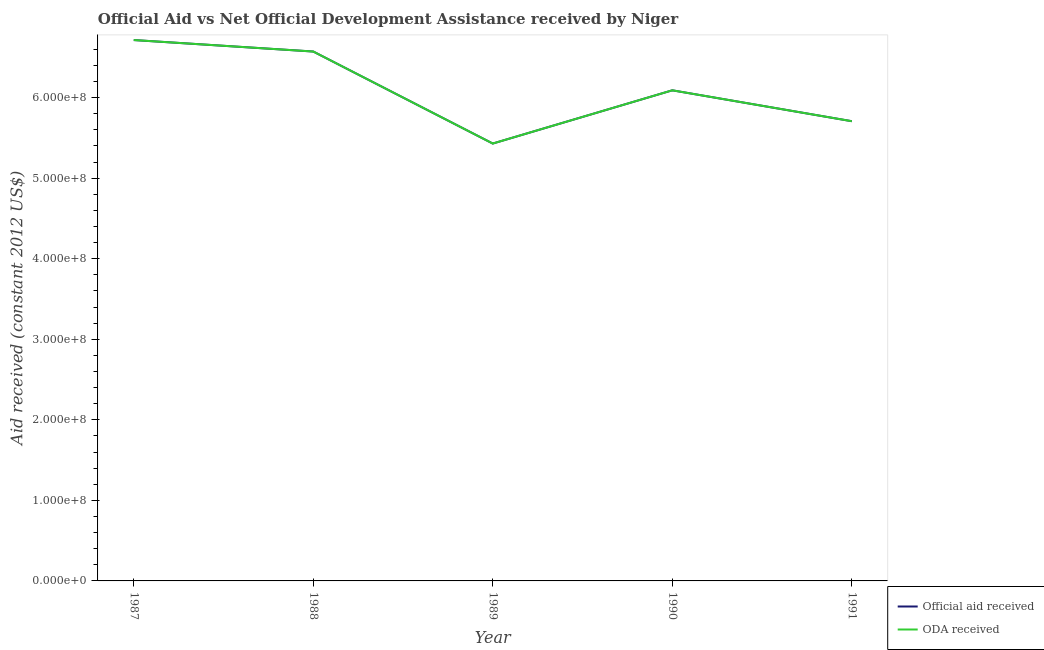How many different coloured lines are there?
Ensure brevity in your answer.  2. Is the number of lines equal to the number of legend labels?
Make the answer very short. Yes. What is the oda received in 1988?
Keep it short and to the point. 6.57e+08. Across all years, what is the maximum official aid received?
Give a very brief answer. 6.72e+08. Across all years, what is the minimum official aid received?
Ensure brevity in your answer.  5.43e+08. What is the total oda received in the graph?
Your answer should be very brief. 3.05e+09. What is the difference between the official aid received in 1989 and that in 1990?
Offer a terse response. -6.61e+07. What is the difference between the official aid received in 1989 and the oda received in 1987?
Keep it short and to the point. -1.28e+08. What is the average official aid received per year?
Provide a short and direct response. 6.10e+08. In the year 1987, what is the difference between the official aid received and oda received?
Your answer should be compact. 0. In how many years, is the oda received greater than 160000000 US$?
Your answer should be very brief. 5. What is the ratio of the official aid received in 1987 to that in 1991?
Provide a succinct answer. 1.18. Is the difference between the official aid received in 1987 and 1990 greater than the difference between the oda received in 1987 and 1990?
Ensure brevity in your answer.  No. What is the difference between the highest and the second highest oda received?
Make the answer very short. 1.42e+07. What is the difference between the highest and the lowest oda received?
Give a very brief answer. 1.28e+08. Does the official aid received monotonically increase over the years?
Provide a succinct answer. No. Is the oda received strictly less than the official aid received over the years?
Make the answer very short. No. How many lines are there?
Provide a succinct answer. 2. How many years are there in the graph?
Your response must be concise. 5. What is the difference between two consecutive major ticks on the Y-axis?
Your answer should be compact. 1.00e+08. Are the values on the major ticks of Y-axis written in scientific E-notation?
Give a very brief answer. Yes. Does the graph contain any zero values?
Ensure brevity in your answer.  No. Does the graph contain grids?
Your response must be concise. No. Where does the legend appear in the graph?
Provide a succinct answer. Bottom right. How are the legend labels stacked?
Provide a short and direct response. Vertical. What is the title of the graph?
Your answer should be very brief. Official Aid vs Net Official Development Assistance received by Niger . Does "Male labourers" appear as one of the legend labels in the graph?
Your answer should be compact. No. What is the label or title of the X-axis?
Make the answer very short. Year. What is the label or title of the Y-axis?
Provide a short and direct response. Aid received (constant 2012 US$). What is the Aid received (constant 2012 US$) in Official aid received in 1987?
Your answer should be very brief. 6.72e+08. What is the Aid received (constant 2012 US$) in ODA received in 1987?
Ensure brevity in your answer.  6.72e+08. What is the Aid received (constant 2012 US$) of Official aid received in 1988?
Your response must be concise. 6.57e+08. What is the Aid received (constant 2012 US$) of ODA received in 1988?
Make the answer very short. 6.57e+08. What is the Aid received (constant 2012 US$) of Official aid received in 1989?
Your answer should be compact. 5.43e+08. What is the Aid received (constant 2012 US$) in ODA received in 1989?
Make the answer very short. 5.43e+08. What is the Aid received (constant 2012 US$) in Official aid received in 1990?
Keep it short and to the point. 6.09e+08. What is the Aid received (constant 2012 US$) of ODA received in 1990?
Your answer should be compact. 6.09e+08. What is the Aid received (constant 2012 US$) in Official aid received in 1991?
Give a very brief answer. 5.71e+08. What is the Aid received (constant 2012 US$) of ODA received in 1991?
Make the answer very short. 5.71e+08. Across all years, what is the maximum Aid received (constant 2012 US$) of Official aid received?
Your answer should be very brief. 6.72e+08. Across all years, what is the maximum Aid received (constant 2012 US$) in ODA received?
Your answer should be compact. 6.72e+08. Across all years, what is the minimum Aid received (constant 2012 US$) in Official aid received?
Offer a very short reply. 5.43e+08. Across all years, what is the minimum Aid received (constant 2012 US$) in ODA received?
Ensure brevity in your answer.  5.43e+08. What is the total Aid received (constant 2012 US$) of Official aid received in the graph?
Your answer should be compact. 3.05e+09. What is the total Aid received (constant 2012 US$) in ODA received in the graph?
Your response must be concise. 3.05e+09. What is the difference between the Aid received (constant 2012 US$) of Official aid received in 1987 and that in 1988?
Provide a short and direct response. 1.42e+07. What is the difference between the Aid received (constant 2012 US$) of ODA received in 1987 and that in 1988?
Your answer should be compact. 1.42e+07. What is the difference between the Aid received (constant 2012 US$) in Official aid received in 1987 and that in 1989?
Provide a short and direct response. 1.28e+08. What is the difference between the Aid received (constant 2012 US$) in ODA received in 1987 and that in 1989?
Provide a short and direct response. 1.28e+08. What is the difference between the Aid received (constant 2012 US$) in Official aid received in 1987 and that in 1990?
Your response must be concise. 6.24e+07. What is the difference between the Aid received (constant 2012 US$) in ODA received in 1987 and that in 1990?
Your answer should be compact. 6.24e+07. What is the difference between the Aid received (constant 2012 US$) in Official aid received in 1987 and that in 1991?
Offer a very short reply. 1.01e+08. What is the difference between the Aid received (constant 2012 US$) in ODA received in 1987 and that in 1991?
Give a very brief answer. 1.01e+08. What is the difference between the Aid received (constant 2012 US$) of Official aid received in 1988 and that in 1989?
Keep it short and to the point. 1.14e+08. What is the difference between the Aid received (constant 2012 US$) in ODA received in 1988 and that in 1989?
Keep it short and to the point. 1.14e+08. What is the difference between the Aid received (constant 2012 US$) of Official aid received in 1988 and that in 1990?
Your response must be concise. 4.82e+07. What is the difference between the Aid received (constant 2012 US$) of ODA received in 1988 and that in 1990?
Your answer should be compact. 4.82e+07. What is the difference between the Aid received (constant 2012 US$) in Official aid received in 1988 and that in 1991?
Your answer should be very brief. 8.65e+07. What is the difference between the Aid received (constant 2012 US$) of ODA received in 1988 and that in 1991?
Your answer should be compact. 8.65e+07. What is the difference between the Aid received (constant 2012 US$) in Official aid received in 1989 and that in 1990?
Keep it short and to the point. -6.61e+07. What is the difference between the Aid received (constant 2012 US$) of ODA received in 1989 and that in 1990?
Offer a very short reply. -6.61e+07. What is the difference between the Aid received (constant 2012 US$) in Official aid received in 1989 and that in 1991?
Offer a very short reply. -2.77e+07. What is the difference between the Aid received (constant 2012 US$) of ODA received in 1989 and that in 1991?
Ensure brevity in your answer.  -2.77e+07. What is the difference between the Aid received (constant 2012 US$) of Official aid received in 1990 and that in 1991?
Keep it short and to the point. 3.84e+07. What is the difference between the Aid received (constant 2012 US$) in ODA received in 1990 and that in 1991?
Your response must be concise. 3.84e+07. What is the difference between the Aid received (constant 2012 US$) in Official aid received in 1987 and the Aid received (constant 2012 US$) in ODA received in 1988?
Ensure brevity in your answer.  1.42e+07. What is the difference between the Aid received (constant 2012 US$) in Official aid received in 1987 and the Aid received (constant 2012 US$) in ODA received in 1989?
Your response must be concise. 1.28e+08. What is the difference between the Aid received (constant 2012 US$) of Official aid received in 1987 and the Aid received (constant 2012 US$) of ODA received in 1990?
Offer a terse response. 6.24e+07. What is the difference between the Aid received (constant 2012 US$) in Official aid received in 1987 and the Aid received (constant 2012 US$) in ODA received in 1991?
Provide a succinct answer. 1.01e+08. What is the difference between the Aid received (constant 2012 US$) in Official aid received in 1988 and the Aid received (constant 2012 US$) in ODA received in 1989?
Your answer should be very brief. 1.14e+08. What is the difference between the Aid received (constant 2012 US$) of Official aid received in 1988 and the Aid received (constant 2012 US$) of ODA received in 1990?
Give a very brief answer. 4.82e+07. What is the difference between the Aid received (constant 2012 US$) of Official aid received in 1988 and the Aid received (constant 2012 US$) of ODA received in 1991?
Ensure brevity in your answer.  8.65e+07. What is the difference between the Aid received (constant 2012 US$) in Official aid received in 1989 and the Aid received (constant 2012 US$) in ODA received in 1990?
Provide a succinct answer. -6.61e+07. What is the difference between the Aid received (constant 2012 US$) in Official aid received in 1989 and the Aid received (constant 2012 US$) in ODA received in 1991?
Offer a terse response. -2.77e+07. What is the difference between the Aid received (constant 2012 US$) of Official aid received in 1990 and the Aid received (constant 2012 US$) of ODA received in 1991?
Keep it short and to the point. 3.84e+07. What is the average Aid received (constant 2012 US$) in Official aid received per year?
Offer a very short reply. 6.10e+08. What is the average Aid received (constant 2012 US$) in ODA received per year?
Keep it short and to the point. 6.10e+08. In the year 1988, what is the difference between the Aid received (constant 2012 US$) of Official aid received and Aid received (constant 2012 US$) of ODA received?
Offer a terse response. 0. What is the ratio of the Aid received (constant 2012 US$) of Official aid received in 1987 to that in 1988?
Provide a succinct answer. 1.02. What is the ratio of the Aid received (constant 2012 US$) of ODA received in 1987 to that in 1988?
Offer a terse response. 1.02. What is the ratio of the Aid received (constant 2012 US$) in Official aid received in 1987 to that in 1989?
Your answer should be very brief. 1.24. What is the ratio of the Aid received (constant 2012 US$) of ODA received in 1987 to that in 1989?
Provide a short and direct response. 1.24. What is the ratio of the Aid received (constant 2012 US$) of Official aid received in 1987 to that in 1990?
Give a very brief answer. 1.1. What is the ratio of the Aid received (constant 2012 US$) of ODA received in 1987 to that in 1990?
Keep it short and to the point. 1.1. What is the ratio of the Aid received (constant 2012 US$) in Official aid received in 1987 to that in 1991?
Your response must be concise. 1.18. What is the ratio of the Aid received (constant 2012 US$) of ODA received in 1987 to that in 1991?
Provide a succinct answer. 1.18. What is the ratio of the Aid received (constant 2012 US$) in Official aid received in 1988 to that in 1989?
Provide a short and direct response. 1.21. What is the ratio of the Aid received (constant 2012 US$) of ODA received in 1988 to that in 1989?
Ensure brevity in your answer.  1.21. What is the ratio of the Aid received (constant 2012 US$) of Official aid received in 1988 to that in 1990?
Provide a succinct answer. 1.08. What is the ratio of the Aid received (constant 2012 US$) in ODA received in 1988 to that in 1990?
Make the answer very short. 1.08. What is the ratio of the Aid received (constant 2012 US$) of Official aid received in 1988 to that in 1991?
Your answer should be very brief. 1.15. What is the ratio of the Aid received (constant 2012 US$) in ODA received in 1988 to that in 1991?
Make the answer very short. 1.15. What is the ratio of the Aid received (constant 2012 US$) in Official aid received in 1989 to that in 1990?
Keep it short and to the point. 0.89. What is the ratio of the Aid received (constant 2012 US$) in ODA received in 1989 to that in 1990?
Make the answer very short. 0.89. What is the ratio of the Aid received (constant 2012 US$) in Official aid received in 1989 to that in 1991?
Ensure brevity in your answer.  0.95. What is the ratio of the Aid received (constant 2012 US$) in ODA received in 1989 to that in 1991?
Provide a short and direct response. 0.95. What is the ratio of the Aid received (constant 2012 US$) in Official aid received in 1990 to that in 1991?
Provide a short and direct response. 1.07. What is the ratio of the Aid received (constant 2012 US$) of ODA received in 1990 to that in 1991?
Your answer should be compact. 1.07. What is the difference between the highest and the second highest Aid received (constant 2012 US$) of Official aid received?
Offer a very short reply. 1.42e+07. What is the difference between the highest and the second highest Aid received (constant 2012 US$) of ODA received?
Offer a terse response. 1.42e+07. What is the difference between the highest and the lowest Aid received (constant 2012 US$) in Official aid received?
Provide a short and direct response. 1.28e+08. What is the difference between the highest and the lowest Aid received (constant 2012 US$) in ODA received?
Keep it short and to the point. 1.28e+08. 